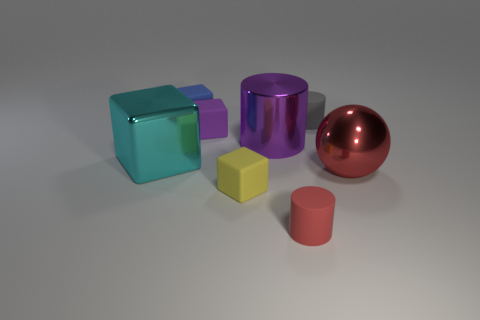There is a tiny matte thing on the right side of the matte cylinder that is in front of the big red sphere; what shape is it?
Your answer should be very brief. Cylinder. How many red things are either large metal cylinders or large objects?
Offer a very short reply. 1. There is a tiny cylinder behind the shiny object in front of the large block; are there any cyan things in front of it?
Give a very brief answer. Yes. The tiny thing that is the same color as the big shiny cylinder is what shape?
Provide a short and direct response. Cube. How many large things are either purple cubes or red balls?
Ensure brevity in your answer.  1. Is the shape of the purple thing on the left side of the purple cylinder the same as  the small blue rubber object?
Provide a short and direct response. Yes. Is the number of big metal objects less than the number of red cylinders?
Make the answer very short. No. Are there any other things that have the same color as the big metal cylinder?
Ensure brevity in your answer.  Yes. The large thing that is in front of the cyan metal block has what shape?
Offer a very short reply. Sphere. Is the color of the large sphere the same as the small matte cylinder that is in front of the purple block?
Provide a succinct answer. Yes. 